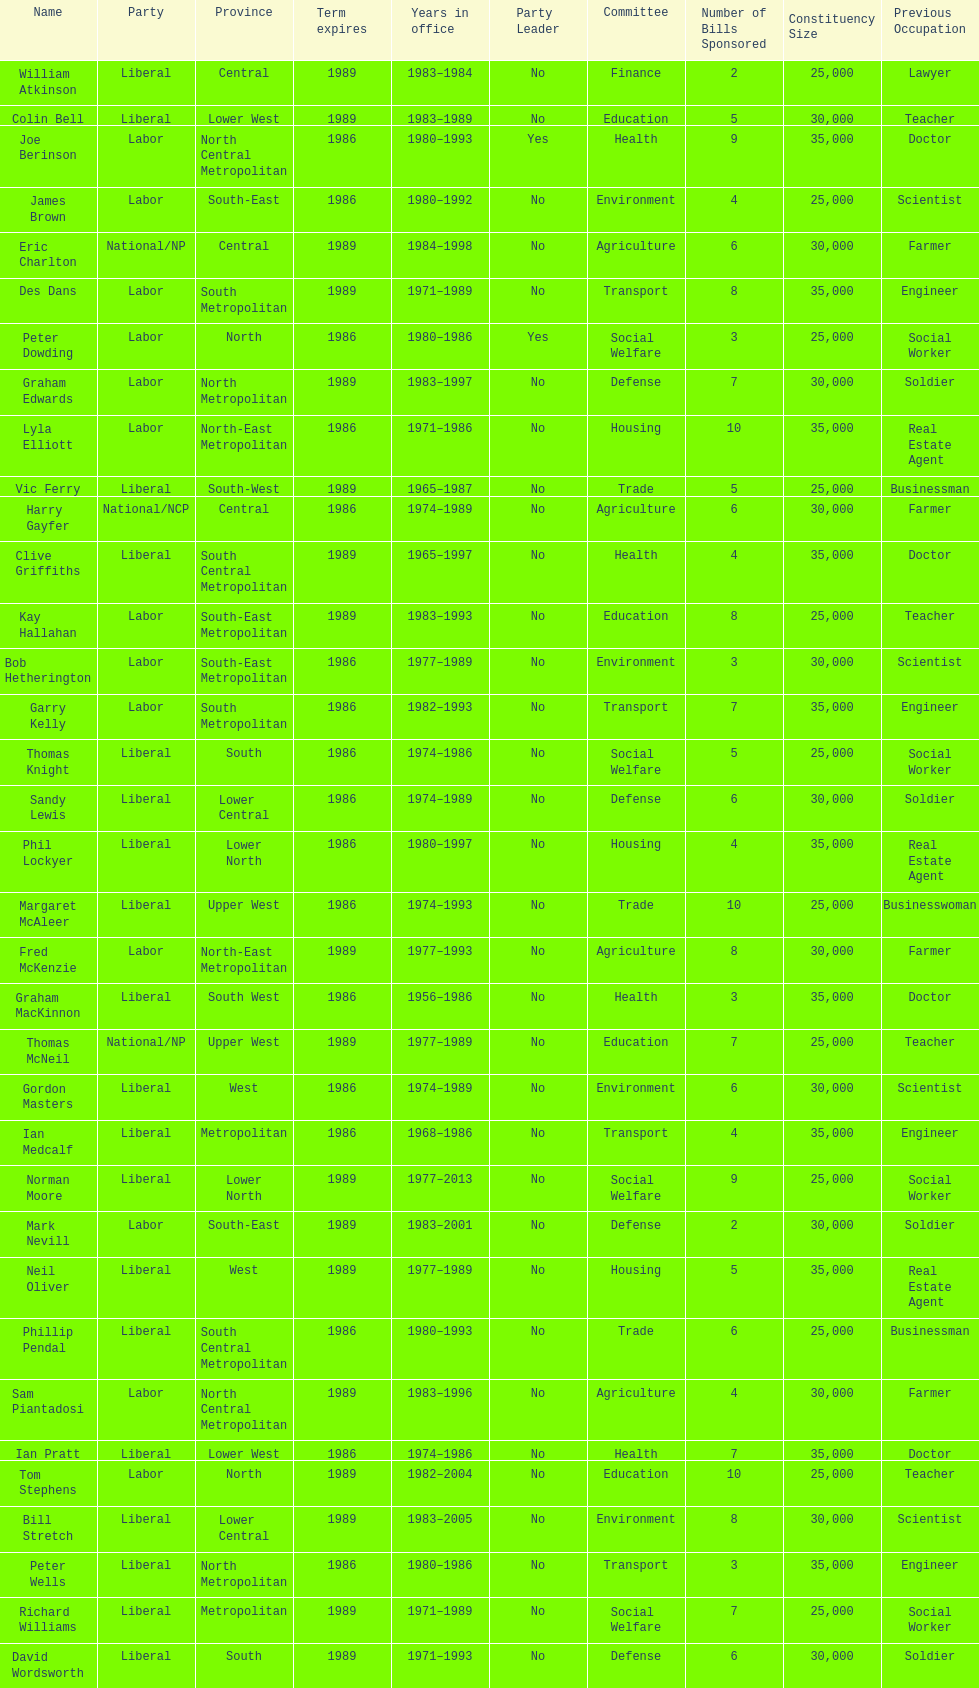Parse the full table. {'header': ['Name', 'Party', 'Province', 'Term expires', 'Years in office', 'Party Leader', 'Committee', 'Number of Bills Sponsored', 'Constituency Size', 'Previous Occupation'], 'rows': [['William Atkinson', 'Liberal', 'Central', '1989', '1983–1984', 'No', 'Finance', '2', '25,000', 'Lawyer'], ['Colin Bell', 'Liberal', 'Lower West', '1989', '1983–1989', 'No', 'Education', '5', '30,000', 'Teacher'], ['Joe Berinson', 'Labor', 'North Central Metropolitan', '1986', '1980–1993', 'Yes', 'Health', '9', '35,000', 'Doctor'], ['James Brown', 'Labor', 'South-East', '1986', '1980–1992', 'No', 'Environment', '4', '25,000', 'Scientist'], ['Eric Charlton', 'National/NP', 'Central', '1989', '1984–1998', 'No', 'Agriculture', '6', '30,000', 'Farmer'], ['Des Dans', 'Labor', 'South Metropolitan', '1989', '1971–1989', 'No', 'Transport', '8', '35,000', 'Engineer'], ['Peter Dowding', 'Labor', 'North', '1986', '1980–1986', 'Yes', 'Social Welfare', '3', '25,000', 'Social Worker'], ['Graham Edwards', 'Labor', 'North Metropolitan', '1989', '1983–1997', 'No', 'Defense', '7', '30,000', 'Soldier'], ['Lyla Elliott', 'Labor', 'North-East Metropolitan', '1986', '1971–1986', 'No', 'Housing', '10', '35,000', 'Real Estate Agent'], ['Vic Ferry', 'Liberal', 'South-West', '1989', '1965–1987', 'No', 'Trade', '5', '25,000', 'Businessman'], ['Harry Gayfer', 'National/NCP', 'Central', '1986', '1974–1989', 'No', 'Agriculture', '6', '30,000', 'Farmer'], ['Clive Griffiths', 'Liberal', 'South Central Metropolitan', '1989', '1965–1997', 'No', 'Health', '4', '35,000', 'Doctor'], ['Kay Hallahan', 'Labor', 'South-East Metropolitan', '1989', '1983–1993', 'No', 'Education', '8', '25,000', 'Teacher'], ['Bob Hetherington', 'Labor', 'South-East Metropolitan', '1986', '1977–1989', 'No', 'Environment', '3', '30,000', 'Scientist'], ['Garry Kelly', 'Labor', 'South Metropolitan', '1986', '1982–1993', 'No', 'Transport', '7', '35,000', 'Engineer'], ['Thomas Knight', 'Liberal', 'South', '1986', '1974–1986', 'No', 'Social Welfare', '5', '25,000', 'Social Worker'], ['Sandy Lewis', 'Liberal', 'Lower Central', '1986', '1974–1989', 'No', 'Defense', '6', '30,000', 'Soldier'], ['Phil Lockyer', 'Liberal', 'Lower North', '1986', '1980–1997', 'No', 'Housing', '4', '35,000', 'Real Estate Agent'], ['Margaret McAleer', 'Liberal', 'Upper West', '1986', '1974–1993', 'No', 'Trade', '10', '25,000', 'Businesswoman'], ['Fred McKenzie', 'Labor', 'North-East Metropolitan', '1989', '1977–1993', 'No', 'Agriculture', '8', '30,000', 'Farmer'], ['Graham MacKinnon', 'Liberal', 'South West', '1986', '1956–1986', 'No', 'Health', '3', '35,000', 'Doctor'], ['Thomas McNeil', 'National/NP', 'Upper West', '1989', '1977–1989', 'No', 'Education', '7', '25,000', 'Teacher'], ['Gordon Masters', 'Liberal', 'West', '1986', '1974–1989', 'No', 'Environment', '6', '30,000', 'Scientist'], ['Ian Medcalf', 'Liberal', 'Metropolitan', '1986', '1968–1986', 'No', 'Transport', '4', '35,000', 'Engineer'], ['Norman Moore', 'Liberal', 'Lower North', '1989', '1977–2013', 'No', 'Social Welfare', '9', '25,000', 'Social Worker'], ['Mark Nevill', 'Labor', 'South-East', '1989', '1983–2001', 'No', 'Defense', '2', '30,000', 'Soldier'], ['Neil Oliver', 'Liberal', 'West', '1989', '1977–1989', 'No', 'Housing', '5', '35,000', 'Real Estate Agent'], ['Phillip Pendal', 'Liberal', 'South Central Metropolitan', '1986', '1980–1993', 'No', 'Trade', '6', '25,000', 'Businessman'], ['Sam Piantadosi', 'Labor', 'North Central Metropolitan', '1989', '1983–1996', 'No', 'Agriculture', '4', '30,000', 'Farmer'], ['Ian Pratt', 'Liberal', 'Lower West', '1986', '1974–1986', 'No', 'Health', '7', '35,000', 'Doctor'], ['Tom Stephens', 'Labor', 'North', '1989', '1982–2004', 'No', 'Education', '10', '25,000', 'Teacher'], ['Bill Stretch', 'Liberal', 'Lower Central', '1989', '1983–2005', 'No', 'Environment', '8', '30,000', 'Scientist'], ['Peter Wells', 'Liberal', 'North Metropolitan', '1986', '1980–1986', 'No', 'Transport', '3', '35,000', 'Engineer'], ['Richard Williams', 'Liberal', 'Metropolitan', '1989', '1971–1989', 'No', 'Social Welfare', '7', '25,000', 'Social Worker'], ['David Wordsworth', 'Liberal', 'South', '1989', '1971–1993', 'No', 'Defense', '6', '30,000', 'Soldier']]} How many members were party of lower west province? 2. 